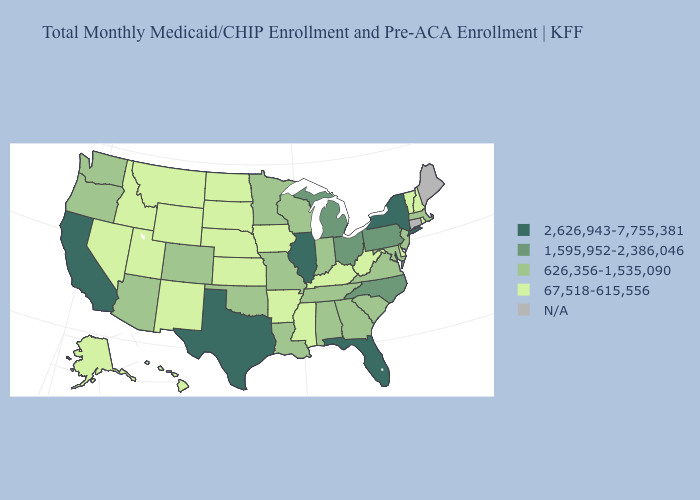Does Texas have the highest value in the South?
Write a very short answer. Yes. Does the map have missing data?
Answer briefly. Yes. Name the states that have a value in the range 2,626,943-7,755,381?
Give a very brief answer. California, Florida, Illinois, New York, Texas. What is the value of Connecticut?
Keep it brief. N/A. What is the value of Iowa?
Concise answer only. 67,518-615,556. Name the states that have a value in the range 2,626,943-7,755,381?
Concise answer only. California, Florida, Illinois, New York, Texas. Is the legend a continuous bar?
Keep it brief. No. What is the value of Arkansas?
Quick response, please. 67,518-615,556. What is the highest value in the USA?
Quick response, please. 2,626,943-7,755,381. What is the value of Texas?
Write a very short answer. 2,626,943-7,755,381. What is the value of Nebraska?
Short answer required. 67,518-615,556. Among the states that border Tennessee , which have the lowest value?
Concise answer only. Arkansas, Kentucky, Mississippi. Among the states that border Kentucky , does Illinois have the lowest value?
Write a very short answer. No. What is the value of Colorado?
Write a very short answer. 626,356-1,535,090. Which states have the highest value in the USA?
Keep it brief. California, Florida, Illinois, New York, Texas. 